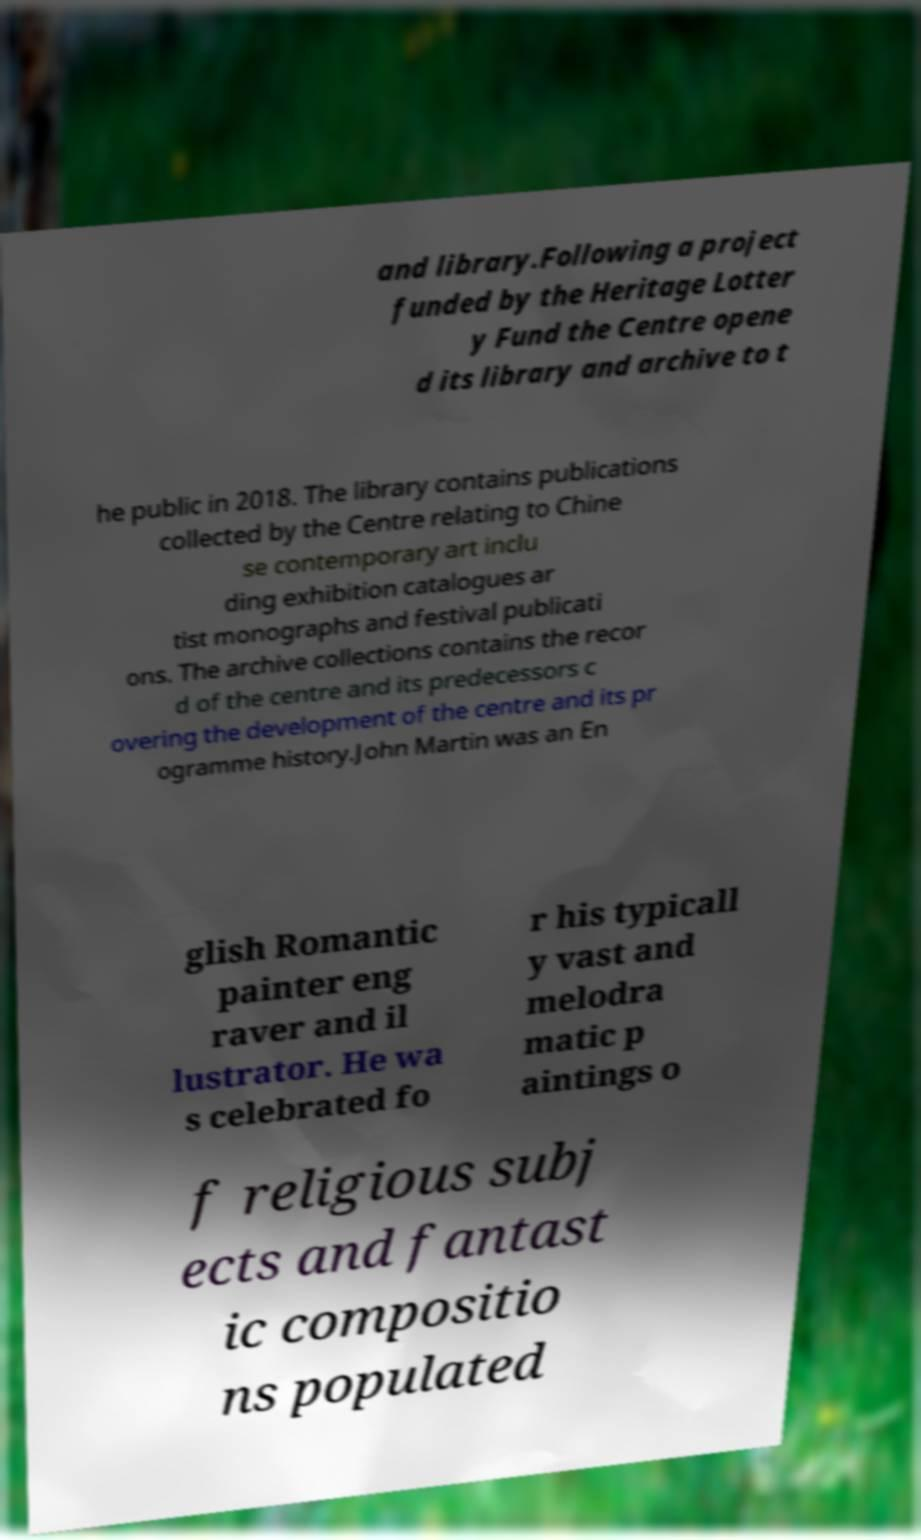For documentation purposes, I need the text within this image transcribed. Could you provide that? and library.Following a project funded by the Heritage Lotter y Fund the Centre opene d its library and archive to t he public in 2018. The library contains publications collected by the Centre relating to Chine se contemporary art inclu ding exhibition catalogues ar tist monographs and festival publicati ons. The archive collections contains the recor d of the centre and its predecessors c overing the development of the centre and its pr ogramme history.John Martin was an En glish Romantic painter eng raver and il lustrator. He wa s celebrated fo r his typicall y vast and melodra matic p aintings o f religious subj ects and fantast ic compositio ns populated 